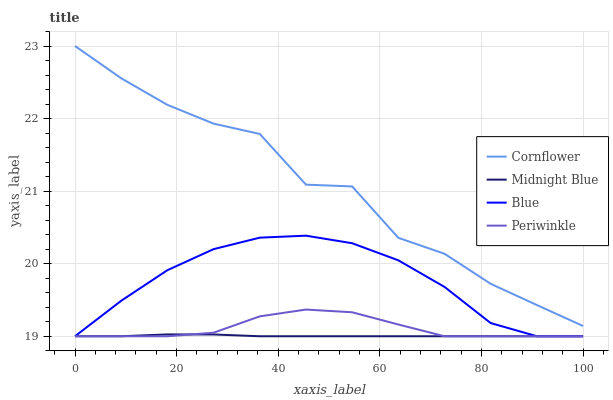Does Midnight Blue have the minimum area under the curve?
Answer yes or no. Yes. Does Cornflower have the maximum area under the curve?
Answer yes or no. Yes. Does Periwinkle have the minimum area under the curve?
Answer yes or no. No. Does Periwinkle have the maximum area under the curve?
Answer yes or no. No. Is Midnight Blue the smoothest?
Answer yes or no. Yes. Is Cornflower the roughest?
Answer yes or no. Yes. Is Periwinkle the smoothest?
Answer yes or no. No. Is Periwinkle the roughest?
Answer yes or no. No. Does Cornflower have the lowest value?
Answer yes or no. No. Does Cornflower have the highest value?
Answer yes or no. Yes. Does Periwinkle have the highest value?
Answer yes or no. No. Is Midnight Blue less than Cornflower?
Answer yes or no. Yes. Is Cornflower greater than Periwinkle?
Answer yes or no. Yes. Does Blue intersect Midnight Blue?
Answer yes or no. Yes. Is Blue less than Midnight Blue?
Answer yes or no. No. Is Blue greater than Midnight Blue?
Answer yes or no. No. Does Midnight Blue intersect Cornflower?
Answer yes or no. No. 